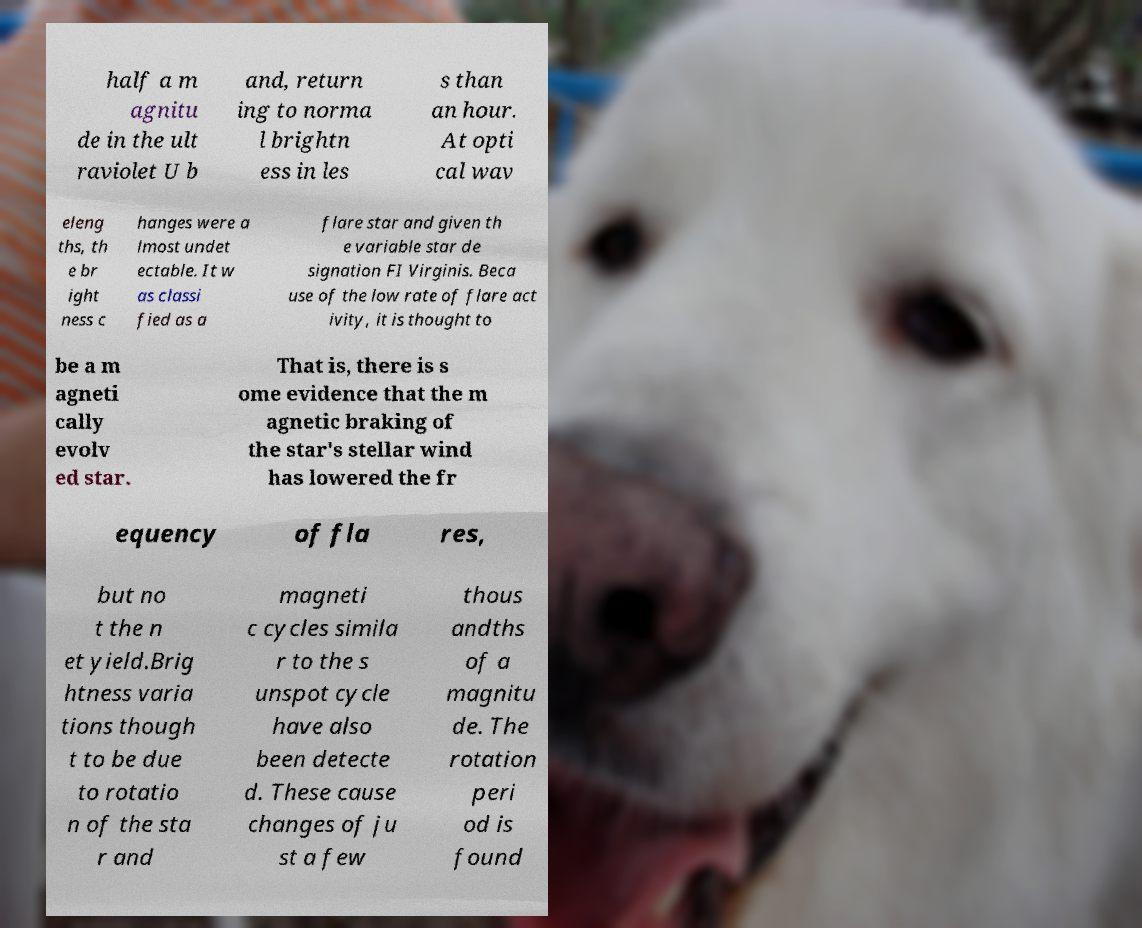I need the written content from this picture converted into text. Can you do that? half a m agnitu de in the ult raviolet U b and, return ing to norma l brightn ess in les s than an hour. At opti cal wav eleng ths, th e br ight ness c hanges were a lmost undet ectable. It w as classi fied as a flare star and given th e variable star de signation FI Virginis. Beca use of the low rate of flare act ivity, it is thought to be a m agneti cally evolv ed star. That is, there is s ome evidence that the m agnetic braking of the star's stellar wind has lowered the fr equency of fla res, but no t the n et yield.Brig htness varia tions though t to be due to rotatio n of the sta r and magneti c cycles simila r to the s unspot cycle have also been detecte d. These cause changes of ju st a few thous andths of a magnitu de. The rotation peri od is found 